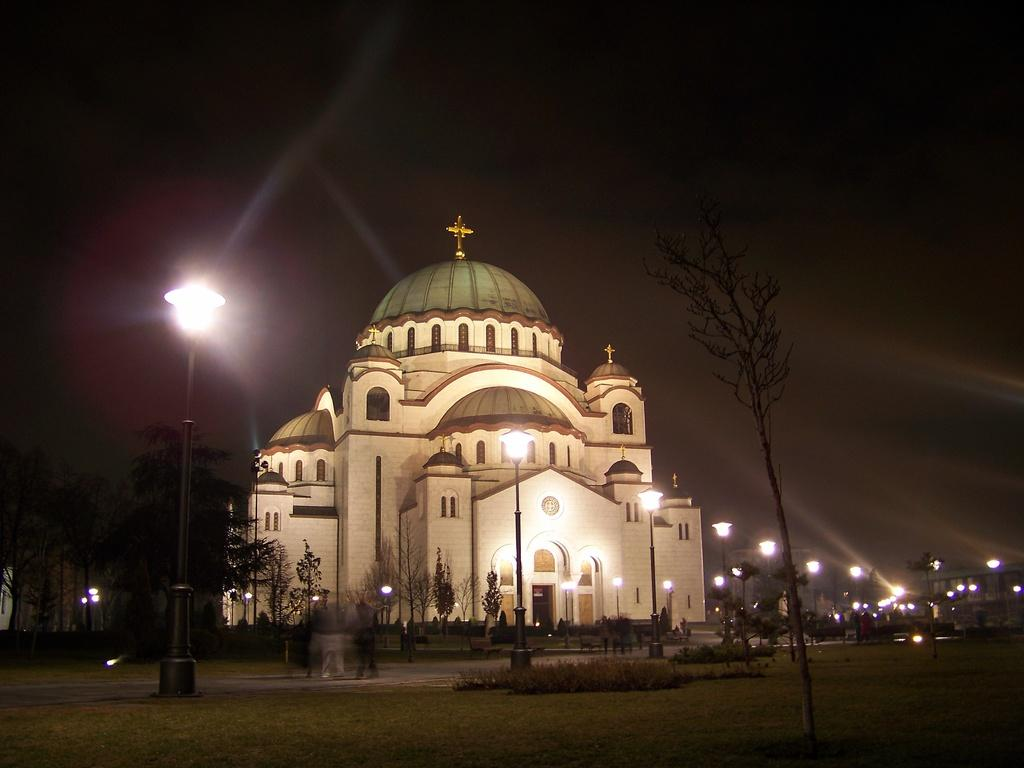Who or what can be seen in the image? There are people in the image. What type of structure is present in the image? There is a house in the image. What are the light sources in the image? There are light poles in the image. What type of vegetation is present in the image? There are plants and trees in the image. What is visible in the background of the image? The sky is visible in the image. What type of apparatus is being used by the people in the image? There is no specific apparatus being used by the people in the image; they are simply present in the scene. What unit of measurement is being used to determine the height of the trees in the image? There is no indication of any unit of measurement being used to determine the height of the trees in the image. 